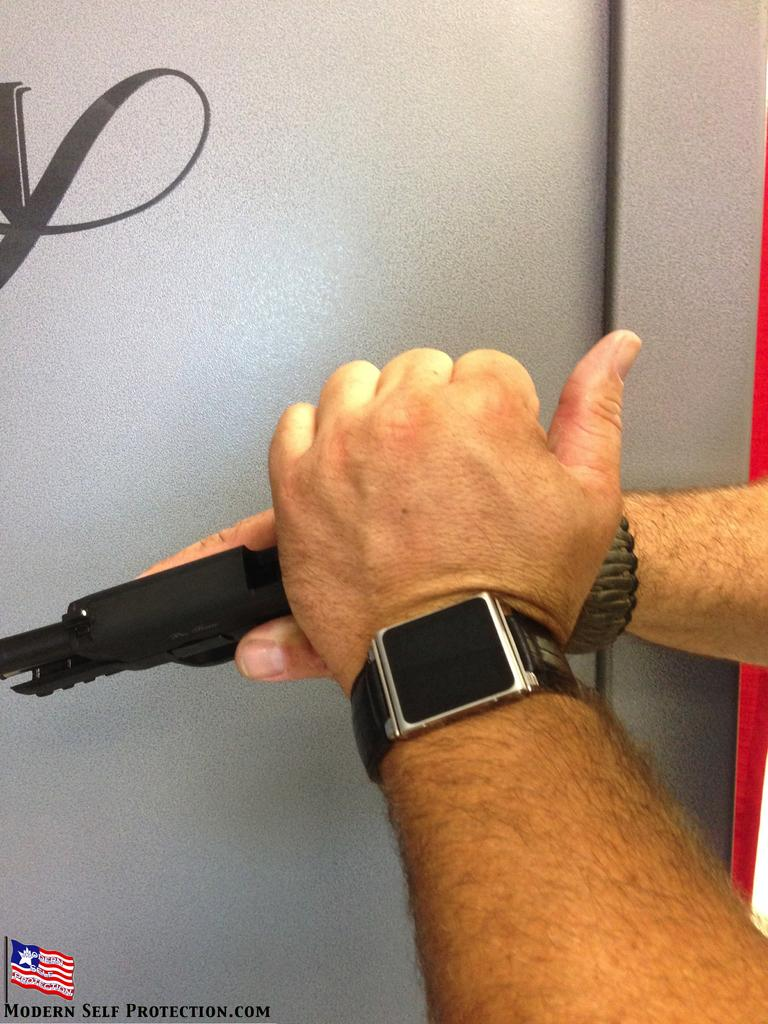<image>
Create a compact narrative representing the image presented. Hands are holding a gun above words "MODERN SELF PROTECTION.COM." 